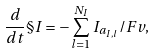<formula> <loc_0><loc_0><loc_500><loc_500>\frac { d } { d t } \S I = - \sum _ { l = 1 } ^ { N _ { I } } I _ { a _ { I , l } } / F v ,</formula> 